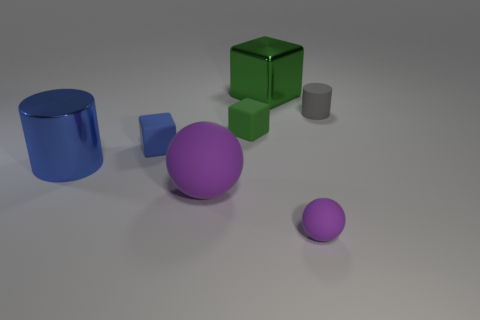There is a matte object that is on the right side of the small green matte thing and in front of the gray cylinder; how big is it?
Give a very brief answer. Small. Is there any other thing that has the same material as the big purple object?
Ensure brevity in your answer.  Yes. Do the small blue cube and the big thing on the right side of the large purple ball have the same material?
Offer a terse response. No. Are there fewer blue matte blocks that are behind the blue metallic object than big green things that are in front of the small blue object?
Provide a short and direct response. No. What material is the cylinder on the left side of the tiny sphere?
Offer a very short reply. Metal. The big thing that is both behind the large sphere and right of the tiny blue matte cube is what color?
Provide a succinct answer. Green. What number of other things are there of the same color as the big rubber sphere?
Give a very brief answer. 1. What color is the large thing that is behind the big blue metallic cylinder?
Give a very brief answer. Green. Is there a rubber ball of the same size as the matte cylinder?
Ensure brevity in your answer.  Yes. What material is the green thing that is the same size as the metallic cylinder?
Your response must be concise. Metal. 